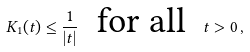Convert formula to latex. <formula><loc_0><loc_0><loc_500><loc_500>K _ { 1 } ( t ) \leq \frac { 1 } { | t | } \ \text { for all } \ t > 0 \, ,</formula> 